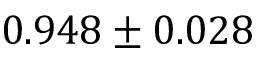<formula> <loc_0><loc_0><loc_500><loc_500>0 . 9 4 8 \pm 0 . 0 2 8</formula> 